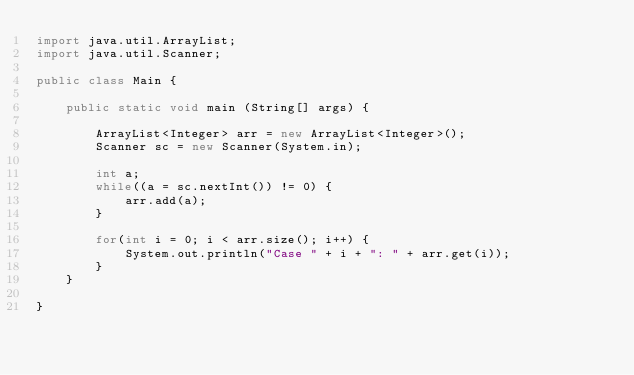<code> <loc_0><loc_0><loc_500><loc_500><_Java_>import java.util.ArrayList;
import java.util.Scanner;

public class Main {

	public static void main (String[] args) {

		ArrayList<Integer> arr = new ArrayList<Integer>();
		Scanner sc = new Scanner(System.in);

		int a;
		while((a = sc.nextInt()) != 0) {
			arr.add(a);
		}

		for(int i = 0; i < arr.size(); i++) {
			System.out.println("Case " + i + ": " + arr.get(i));
		}
	}

}

</code> 